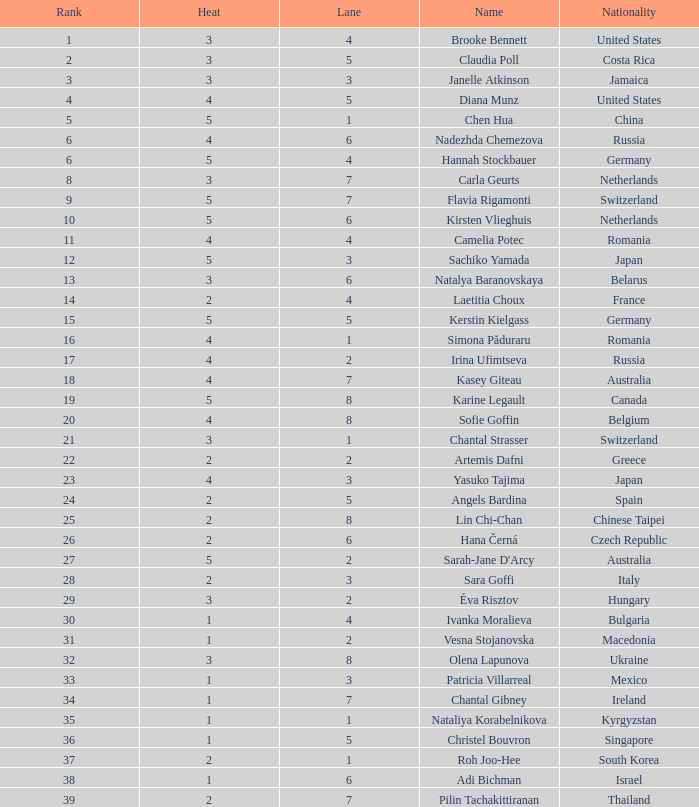Name the total number of lane for brooke bennett and rank less than 1 0.0. 